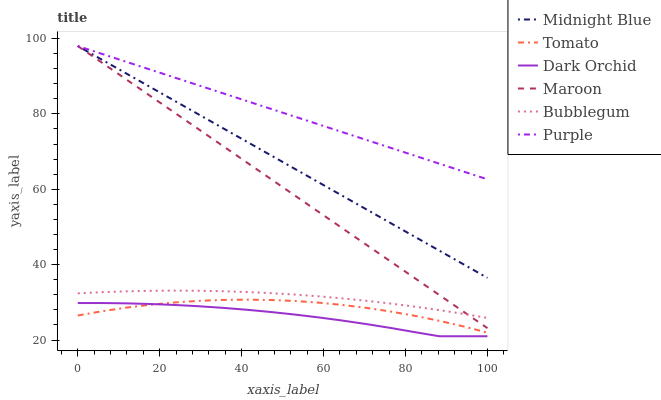Does Dark Orchid have the minimum area under the curve?
Answer yes or no. Yes. Does Purple have the maximum area under the curve?
Answer yes or no. Yes. Does Midnight Blue have the minimum area under the curve?
Answer yes or no. No. Does Midnight Blue have the maximum area under the curve?
Answer yes or no. No. Is Purple the smoothest?
Answer yes or no. Yes. Is Tomato the roughest?
Answer yes or no. Yes. Is Midnight Blue the smoothest?
Answer yes or no. No. Is Midnight Blue the roughest?
Answer yes or no. No. Does Midnight Blue have the lowest value?
Answer yes or no. No. Does Maroon have the highest value?
Answer yes or no. Yes. Does Dark Orchid have the highest value?
Answer yes or no. No. Is Dark Orchid less than Midnight Blue?
Answer yes or no. Yes. Is Midnight Blue greater than Tomato?
Answer yes or no. Yes. Does Bubblegum intersect Maroon?
Answer yes or no. Yes. Is Bubblegum less than Maroon?
Answer yes or no. No. Is Bubblegum greater than Maroon?
Answer yes or no. No. Does Dark Orchid intersect Midnight Blue?
Answer yes or no. No. 